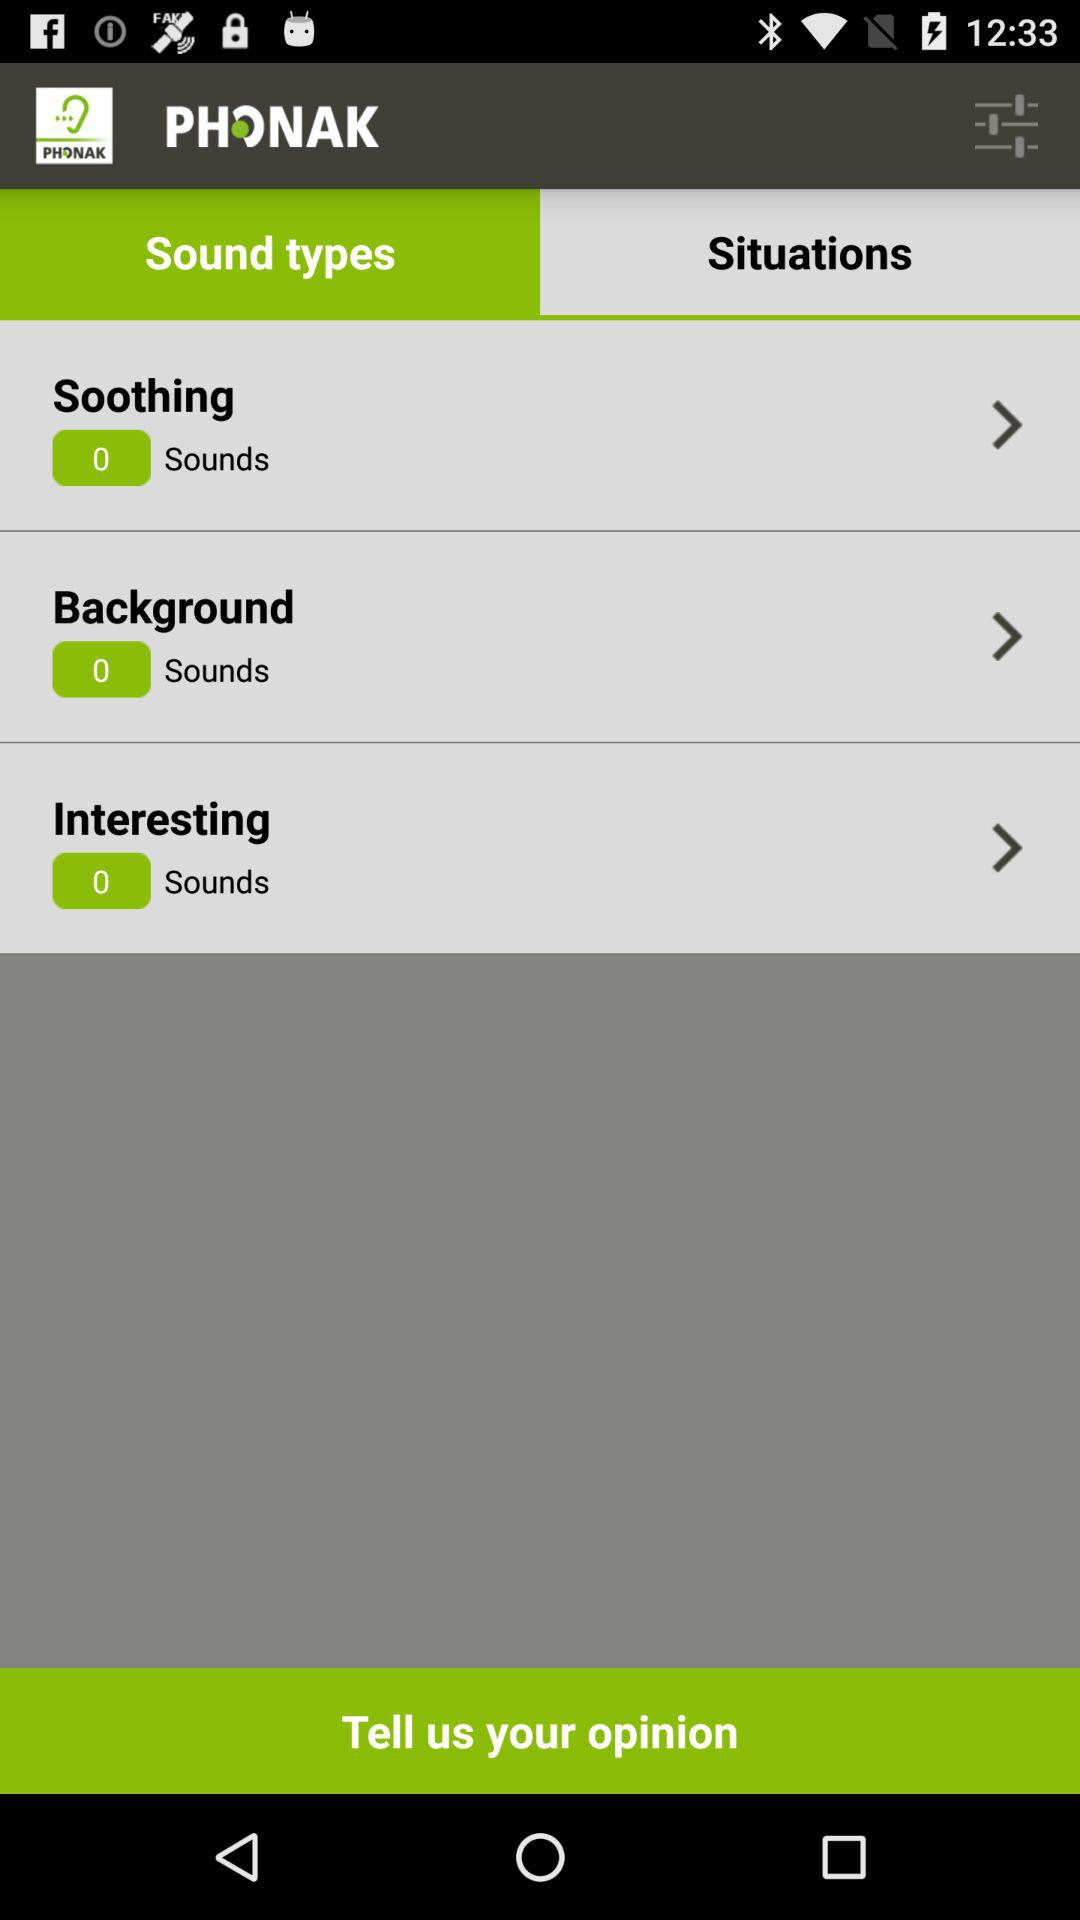How many sounds are in the "Background"? There are 0 sounds in the "Background". 